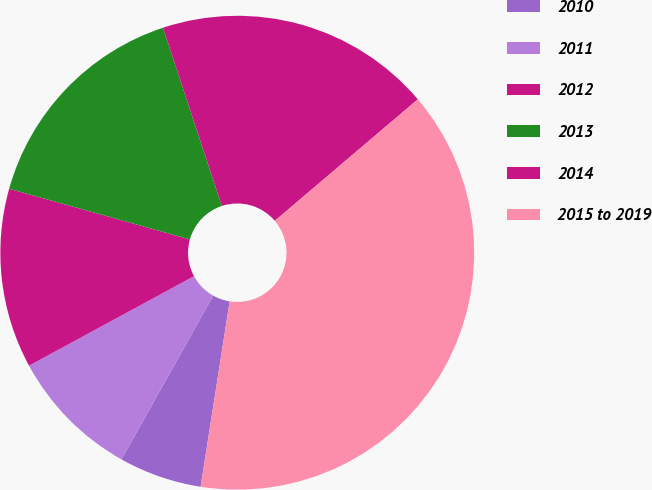Convert chart to OTSL. <chart><loc_0><loc_0><loc_500><loc_500><pie_chart><fcel>2010<fcel>2011<fcel>2012<fcel>2013<fcel>2014<fcel>2015 to 2019<nl><fcel>5.66%<fcel>8.96%<fcel>12.26%<fcel>15.57%<fcel>18.87%<fcel>38.68%<nl></chart> 